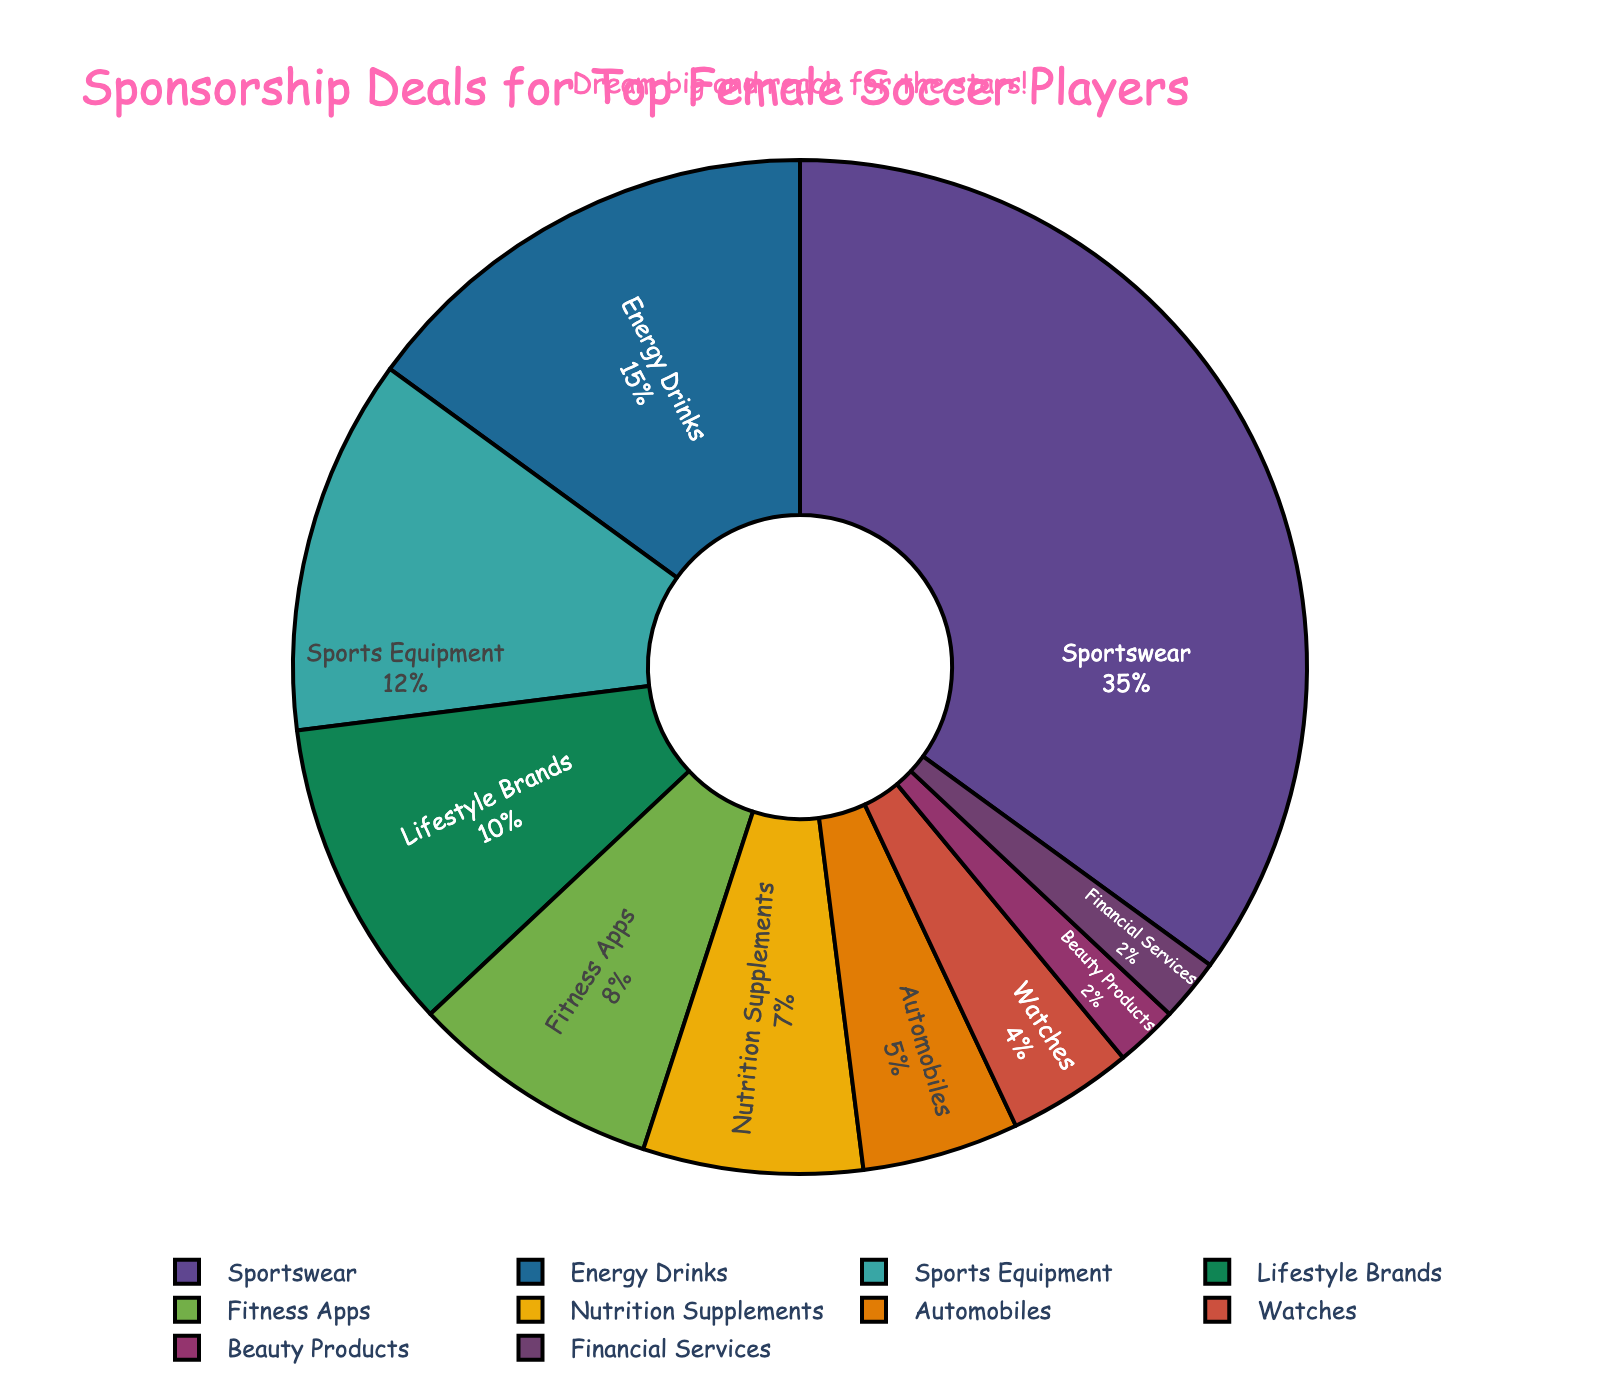Which category has the largest percentage of sponsorship deals? The pie chart shows that "Sportswear" has the largest segment, representing 35% of the sponsorship deals.
Answer: Sportswear What is the combined percentage of sponsorship deals for Energy Drinks and Sports Equipment? The chart shows Energy Drinks at 15% and Sports Equipment at 12%. Combined, they represent 15% + 12% = 27%.
Answer: 27% Which category has fewer sponsorship deals: Automobiles or Watches? The portions for Automobiles and Watches are 5% and 4% respectively, so Watches have fewer deals.
Answer: Watches What is the total percentage of sponsorship deals for Lifestyle Brands, Fitness Apps, and Nutrition Supplements? The figures show Lifestyle Brands with 10%, Fitness Apps with 8%, and Nutrition Supplements with 7%. Summing these: 10% + 8% + 7% = 25%.
Answer: 25% How much greater is the percentage of Sportswear deals compared to Beauty Products deals? Sportswear accounts for 35% and Beauty Products for 2%. The difference is 35% - 2% = 33%.
Answer: 33% Which categories have the same percentage of sponsorship deals? Both Beauty Products and Financial Services have the same percentage of 2%.
Answer: Beauty Products and Financial Services Is the percentage of sponsorship deals for Nutrition Supplements greater than or equal to that of Automobiles? Nutrition Supplements account for 7% while Automobiles account for 5%. 7% is greater than 5%.
Answer: Yes How much more is the percentage of sponsorship deals for Fitness Apps than for Watches? Fitness Apps have 8% and Watches have 4%. The difference is 8% - 4% = 4%.
Answer: 4% If the total percentage for Lifestyle Brands and Energy Drinks were combined, would it be greater or less than Sports Equipment's percentage? Lifestyle Brands are 10% and Energy Drinks are 15%, which combined is 10% + 15% = 25%. This is greater than Sports Equipment's 12%.
Answer: Greater Considering just the three smallest categories, what is their total percentage? The smallest categories—Watches, Beauty Products, and Financial Services—have percentages 4%, 2%, and 2% respectively. Totaling these: 4% + 2% + 2% = 8%.
Answer: 8% 